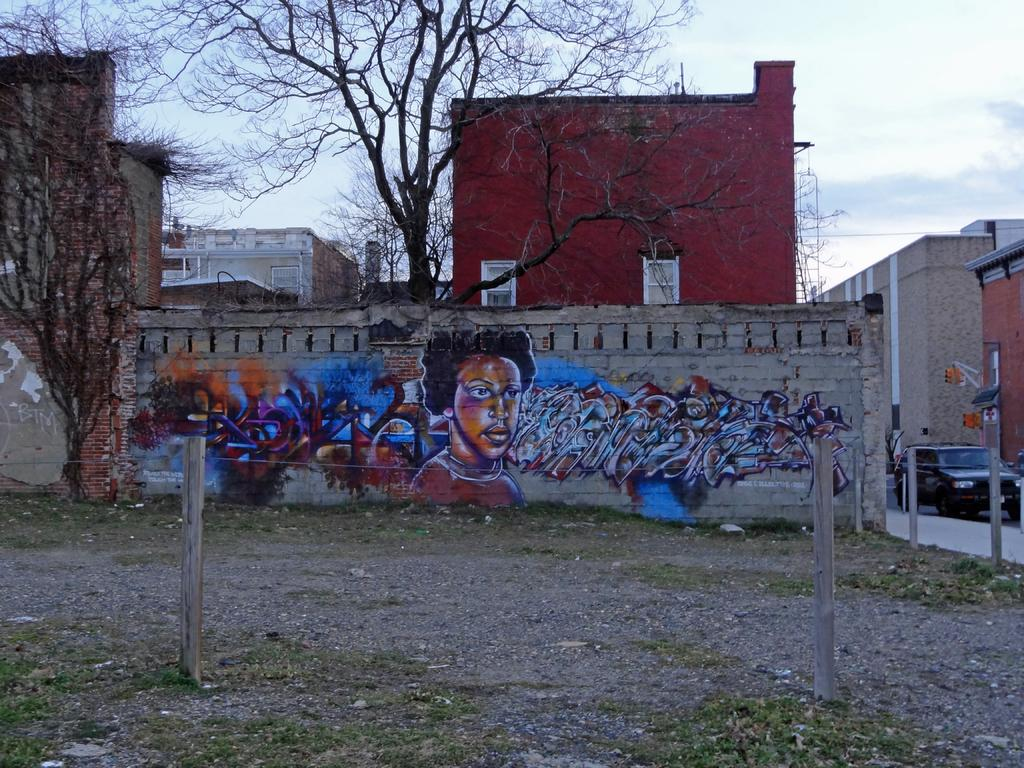What type of vegetation can be seen in the image? There is grass in the image. What structures are present in the image? There are poles, a painting on a wall, a car on the road, and buildings in the image. What other natural elements can be seen in the image? There are trees in the image. What is visible in the background of the image? The sky is visible in the background of the image. How does the beginner show respect to the turkey in the image? There is no beginner, respect, or turkey present in the image. 